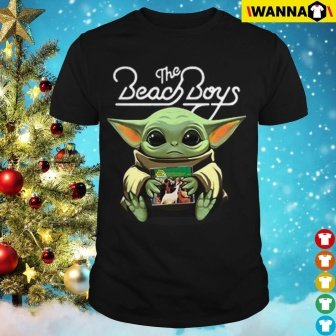How do the Christmas decorations enhance the presentation of the t-shirt? The Christmas tree in the background, adorned with red and gold ornaments, creates a rich, vibrant backdrop that contrasts yet complements the dark hue of the t-shirt. This festive setting not only highlights the t-shirt as a potential holiday gift but also adds a layer of warmth and seasonal cheer. The decorations suggest that the t-shirt could be a thoughtful, themed gift, appealing during the holiday season, and it enhances the visual appeal by situating the product within a recognizable and joyful context. 